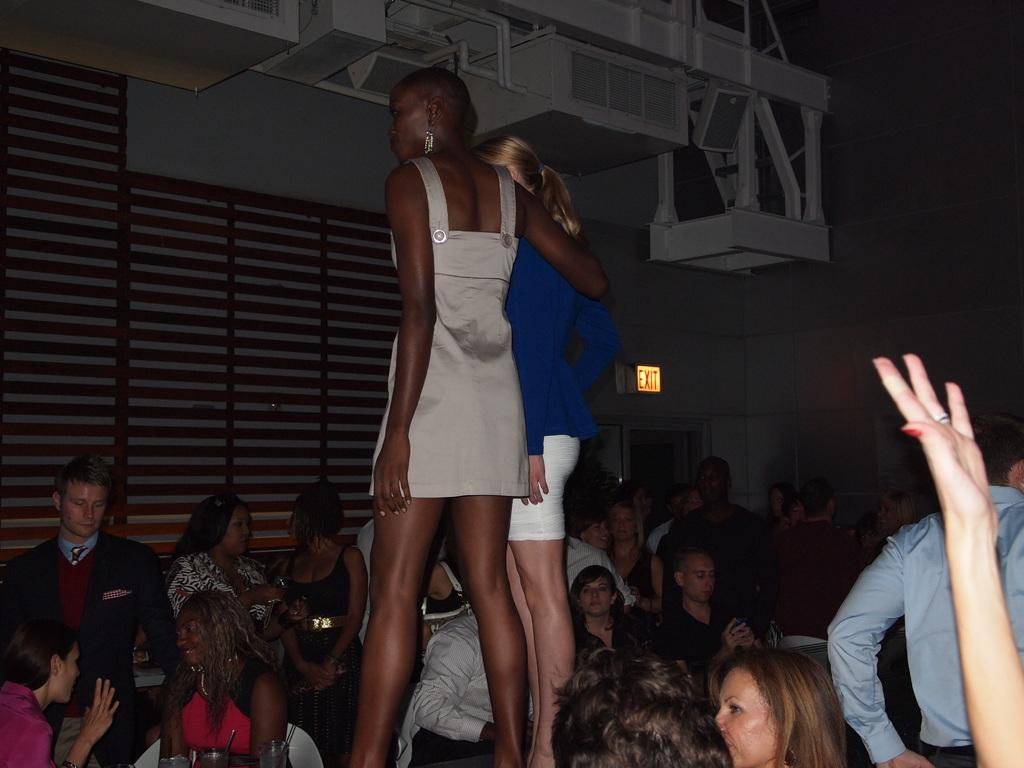How many ladies are present in the image? There are two ladies standing in the image. What are the people at the bottom of the image doing? The people sitting at the bottom of the image are not engaged in any specific activity that can be determined from the facts provided. What can be seen in the background of the image? There is a wall and a door in the background of the image. Can you tell me how many horses are visible in the image? There are no horses present in the image. What type of expansion is shown in the image? There is no expansion depicted in the image; it features two ladies standing, people sitting, and a wall and door in the background. 